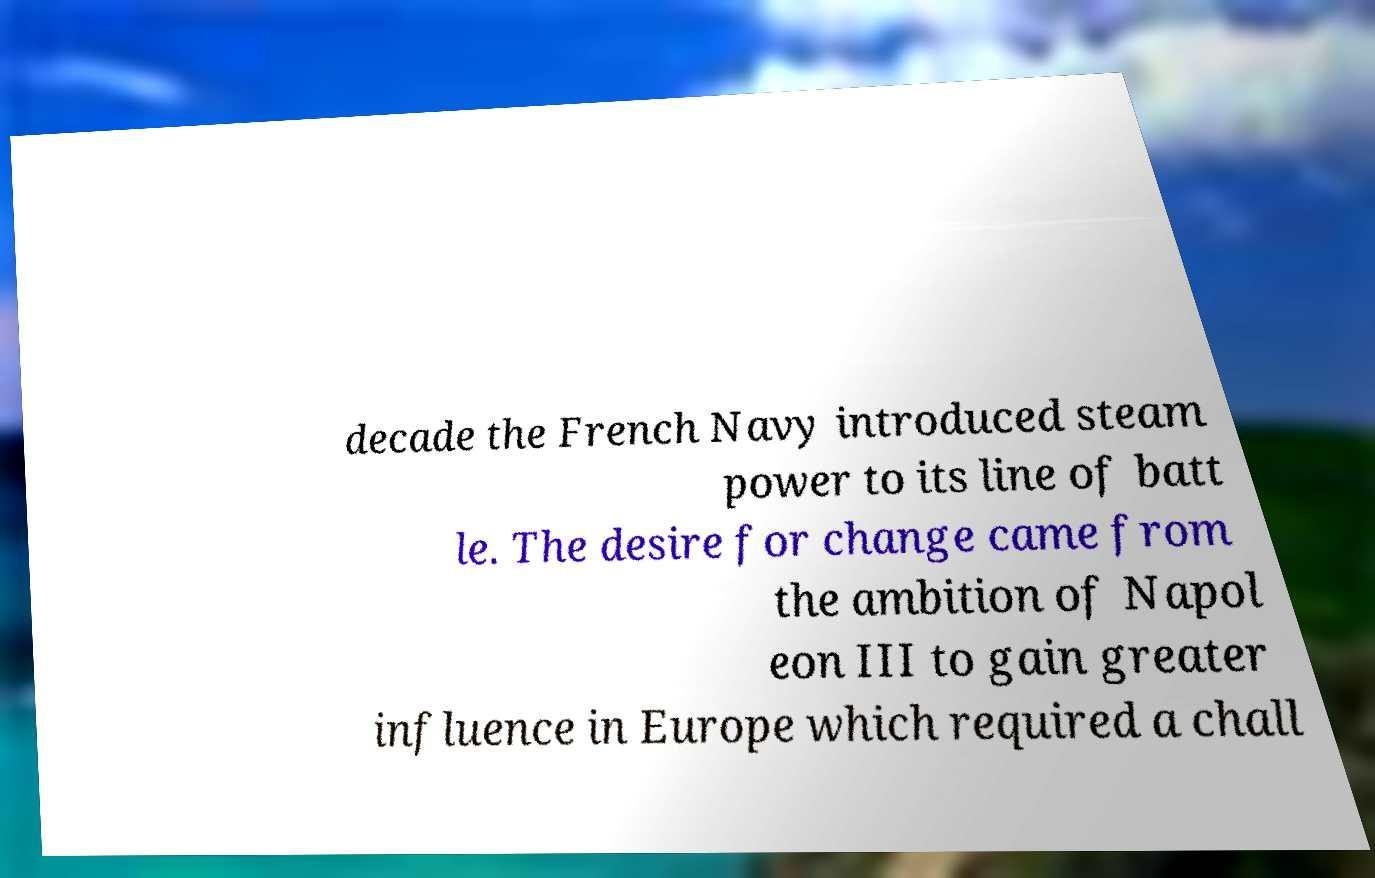Can you accurately transcribe the text from the provided image for me? decade the French Navy introduced steam power to its line of batt le. The desire for change came from the ambition of Napol eon III to gain greater influence in Europe which required a chall 